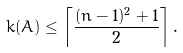<formula> <loc_0><loc_0><loc_500><loc_500>k ( A ) \leq \left \lceil \frac { ( n - 1 ) ^ { 2 } + 1 } { 2 } \right \rceil .</formula> 